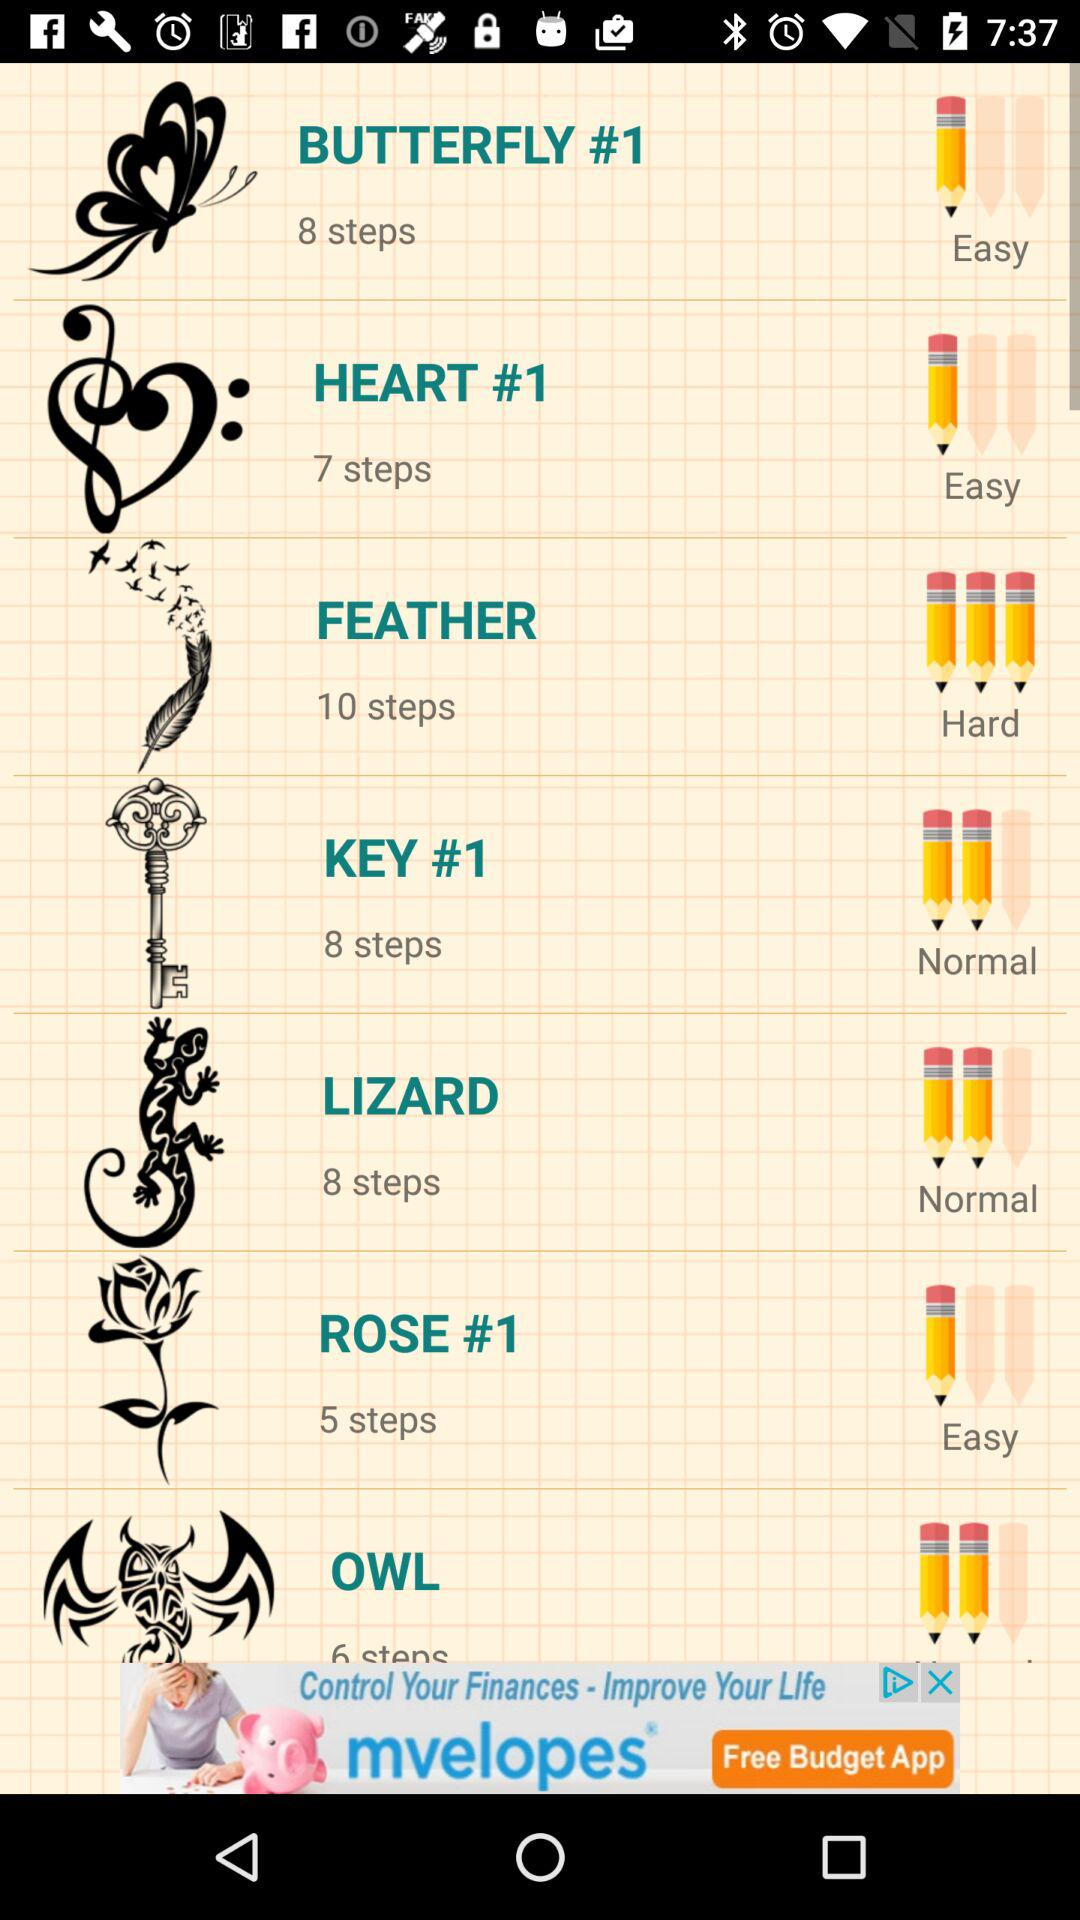What is the step count in the rose? There are 5 steps. 